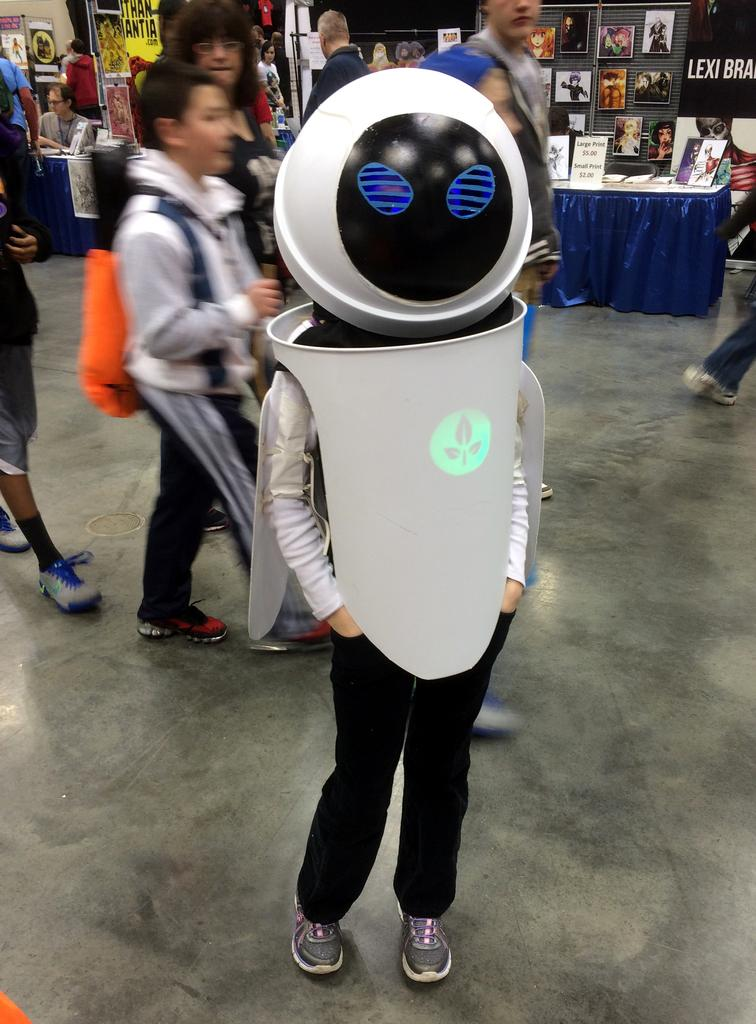What is the person in the foreground of the image wearing? The person in the image is wearing a costume. What can be seen in the background of the image? Other people are present in the background of the image. What color is the table in the image? There is a blue table in the image. What is placed on the blue table? There are photo frames on the blue table. Are there any photo frames visible in the background of the image? Yes, there are additional photo frames in the background of the image. What flavor of grass can be seen in the image? There is no grass present in the image, so it is not possible to determine the flavor of any grass. 